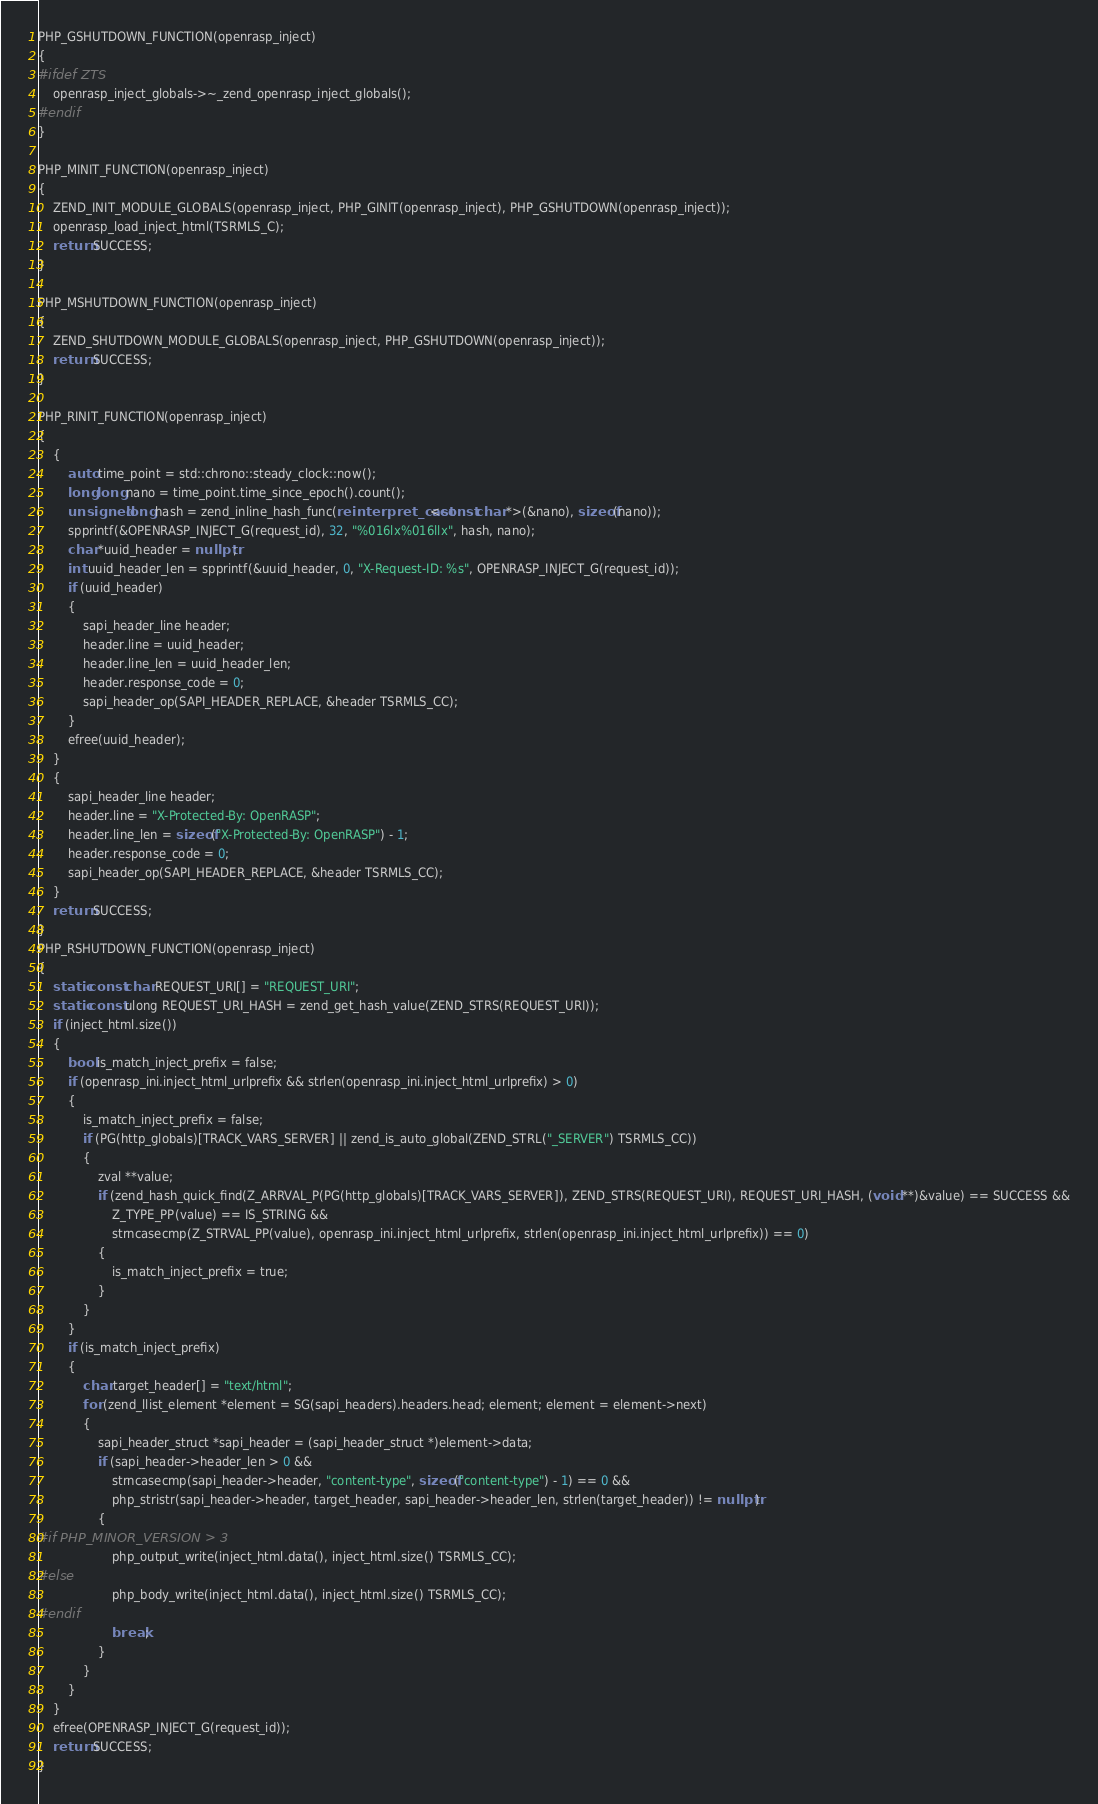Convert code to text. <code><loc_0><loc_0><loc_500><loc_500><_C++_>
PHP_GSHUTDOWN_FUNCTION(openrasp_inject)
{
#ifdef ZTS
    openrasp_inject_globals->~_zend_openrasp_inject_globals();
#endif
}

PHP_MINIT_FUNCTION(openrasp_inject)
{
    ZEND_INIT_MODULE_GLOBALS(openrasp_inject, PHP_GINIT(openrasp_inject), PHP_GSHUTDOWN(openrasp_inject));
    openrasp_load_inject_html(TSRMLS_C);
    return SUCCESS;
}

PHP_MSHUTDOWN_FUNCTION(openrasp_inject)
{
    ZEND_SHUTDOWN_MODULE_GLOBALS(openrasp_inject, PHP_GSHUTDOWN(openrasp_inject));
    return SUCCESS;
}

PHP_RINIT_FUNCTION(openrasp_inject)
{
    {
        auto time_point = std::chrono::steady_clock::now();
        long long nano = time_point.time_since_epoch().count();
        unsigned long hash = zend_inline_hash_func(reinterpret_cast<const char *>(&nano), sizeof(nano));
        spprintf(&OPENRASP_INJECT_G(request_id), 32, "%016lx%016llx", hash, nano);
        char *uuid_header = nullptr;
        int uuid_header_len = spprintf(&uuid_header, 0, "X-Request-ID: %s", OPENRASP_INJECT_G(request_id));
        if (uuid_header)
        {
            sapi_header_line header;
            header.line = uuid_header;
            header.line_len = uuid_header_len;
            header.response_code = 0;
            sapi_header_op(SAPI_HEADER_REPLACE, &header TSRMLS_CC);
        }
        efree(uuid_header);
    }
    {
        sapi_header_line header;
        header.line = "X-Protected-By: OpenRASP";
        header.line_len = sizeof("X-Protected-By: OpenRASP") - 1;
        header.response_code = 0;
        sapi_header_op(SAPI_HEADER_REPLACE, &header TSRMLS_CC);
    }
    return SUCCESS;
}
PHP_RSHUTDOWN_FUNCTION(openrasp_inject)
{
    static const char REQUEST_URI[] = "REQUEST_URI";
    static const ulong REQUEST_URI_HASH = zend_get_hash_value(ZEND_STRS(REQUEST_URI));
    if (inject_html.size())
    {
        bool is_match_inject_prefix = false;
        if (openrasp_ini.inject_html_urlprefix && strlen(openrasp_ini.inject_html_urlprefix) > 0)
        {
            is_match_inject_prefix = false;
            if (PG(http_globals)[TRACK_VARS_SERVER] || zend_is_auto_global(ZEND_STRL("_SERVER") TSRMLS_CC))
            {
                zval **value;
                if (zend_hash_quick_find(Z_ARRVAL_P(PG(http_globals)[TRACK_VARS_SERVER]), ZEND_STRS(REQUEST_URI), REQUEST_URI_HASH, (void **)&value) == SUCCESS &&
                    Z_TYPE_PP(value) == IS_STRING &&
                    strncasecmp(Z_STRVAL_PP(value), openrasp_ini.inject_html_urlprefix, strlen(openrasp_ini.inject_html_urlprefix)) == 0)
                {
                    is_match_inject_prefix = true;
                }
            }
        }
        if (is_match_inject_prefix)
        {
            char target_header[] = "text/html";
            for (zend_llist_element *element = SG(sapi_headers).headers.head; element; element = element->next)
            {
                sapi_header_struct *sapi_header = (sapi_header_struct *)element->data;
                if (sapi_header->header_len > 0 &&
                    strncasecmp(sapi_header->header, "content-type", sizeof("content-type") - 1) == 0 &&
                    php_stristr(sapi_header->header, target_header, sapi_header->header_len, strlen(target_header)) != nullptr)
                {
#if PHP_MINOR_VERSION > 3
                    php_output_write(inject_html.data(), inject_html.size() TSRMLS_CC);
#else
                    php_body_write(inject_html.data(), inject_html.size() TSRMLS_CC);
#endif
                    break;
                }
            }
        }
    }
    efree(OPENRASP_INJECT_G(request_id));
    return SUCCESS;
}</code> 